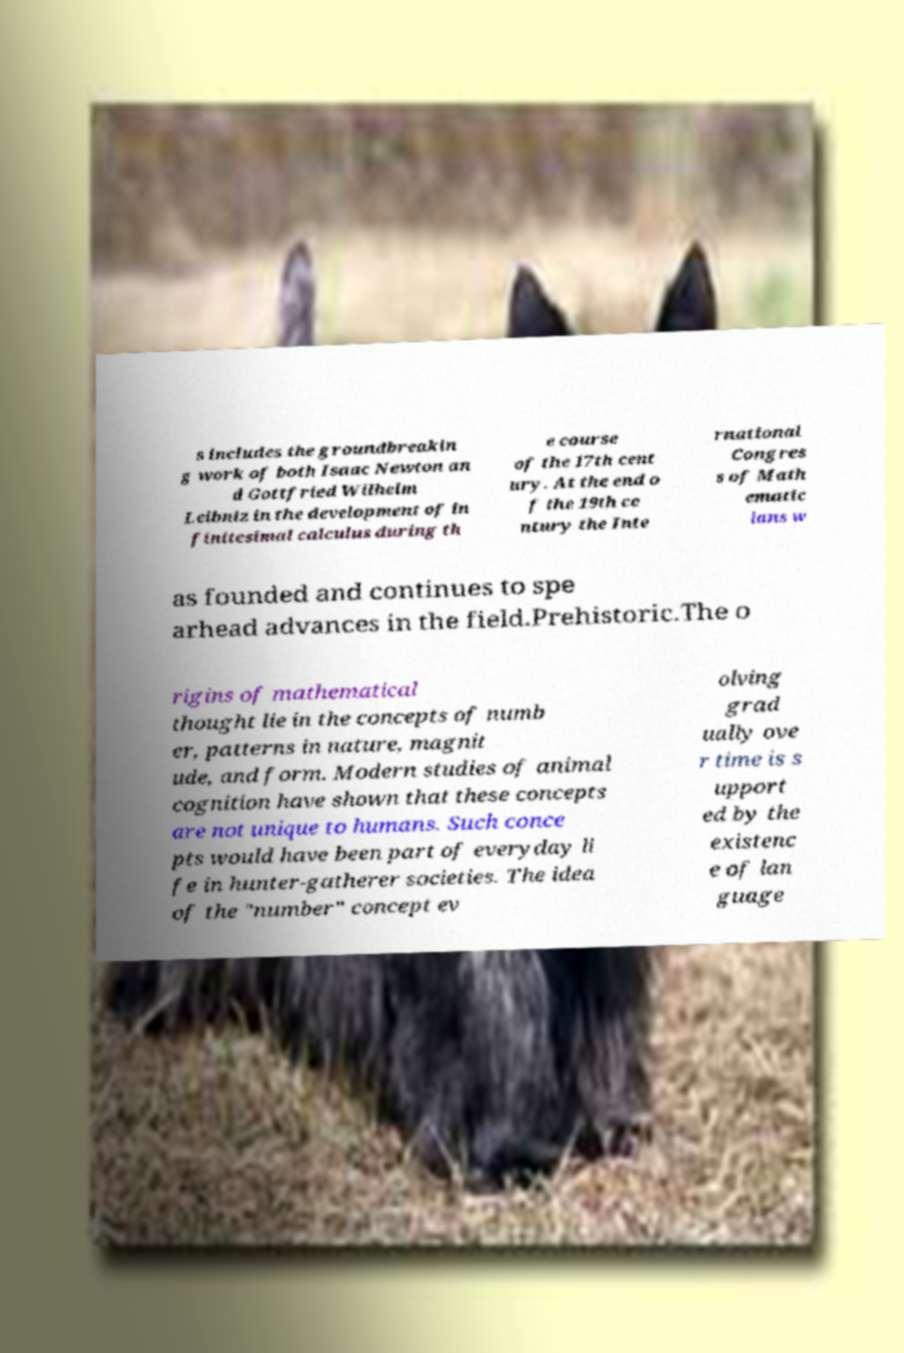What messages or text are displayed in this image? I need them in a readable, typed format. s includes the groundbreakin g work of both Isaac Newton an d Gottfried Wilhelm Leibniz in the development of in finitesimal calculus during th e course of the 17th cent ury. At the end o f the 19th ce ntury the Inte rnational Congres s of Math ematic ians w as founded and continues to spe arhead advances in the field.Prehistoric.The o rigins of mathematical thought lie in the concepts of numb er, patterns in nature, magnit ude, and form. Modern studies of animal cognition have shown that these concepts are not unique to humans. Such conce pts would have been part of everyday li fe in hunter-gatherer societies. The idea of the "number" concept ev olving grad ually ove r time is s upport ed by the existenc e of lan guage 